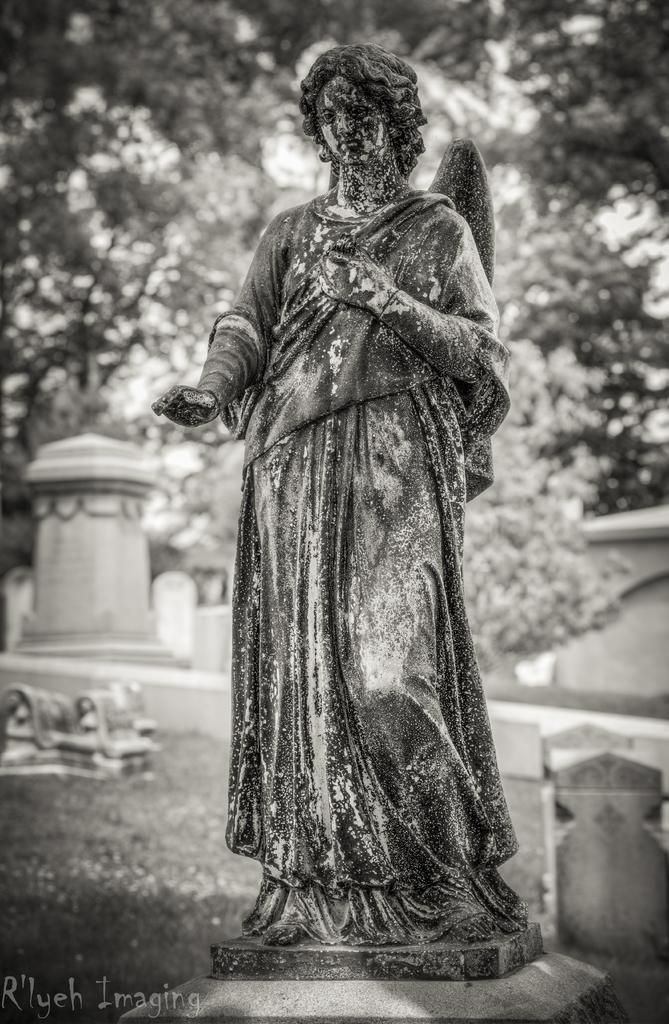Can you describe this image briefly? In the middle of the image we can see a statue, in the background we can see few trees, in the bottom left hand corner we can see some text. 